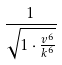Convert formula to latex. <formula><loc_0><loc_0><loc_500><loc_500>\frac { 1 } { \sqrt { 1 \cdot \frac { v ^ { 6 } } { k ^ { 6 } } } }</formula> 